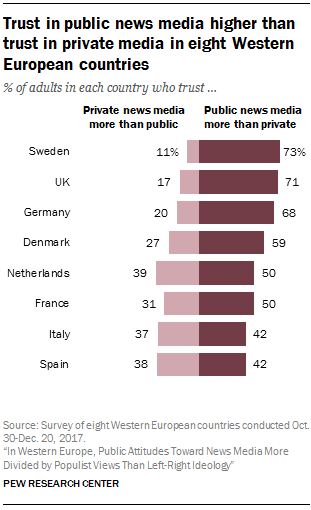List a handful of essential elements in this visual. The largest difference between the right-side and left-side bars is 1.293055556..., and the smallest difference is also 1.293055556... The color of right-side bars is darker than the color of left-side bars. 